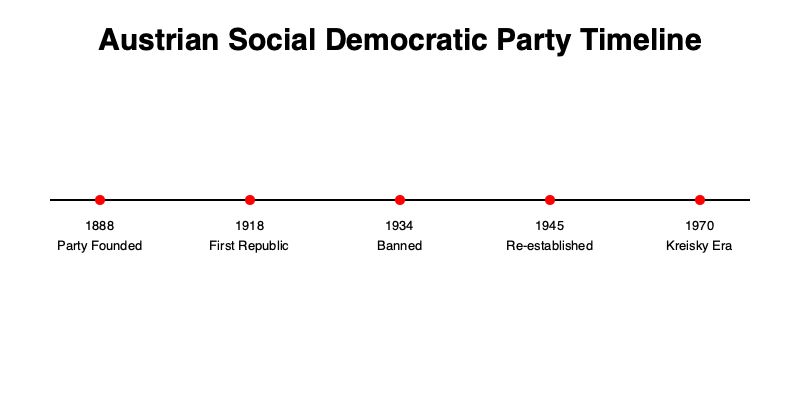According to the timeline, in which year was the Austrian Social Democratic Party banned, and what significant event preceded this ban? To answer this question, we need to examine the timeline carefully:

1. The timeline shows several key events in the history of the Austrian Social Democratic Party.

2. We can see that the party was banned in 1934, as indicated by the event labeled "Banned" on the timeline.

3. To find the significant event that preceded the ban, we need to look at the event immediately before 1934 on the timeline.

4. The event before 1934 is labeled "First Republic" and occurred in 1918.

5. The First Republic refers to the establishment of Austria as a democratic republic after the fall of the Austro-Hungarian Empire at the end of World War I.

6. This period of democratic rule lasted until 1934 when the party was banned, marking the end of the First Republic and the beginning of the Austrofascist regime.

Therefore, the Austrian Social Democratic Party was banned in 1934, and the significant event that preceded this ban was the establishment of the First Republic in 1918.
Answer: 1934; First Republic (1918) 